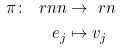Convert formula to latex. <formula><loc_0><loc_0><loc_500><loc_500>\pi \colon \ r n n & \to \ r n \\ e _ { j } & \mapsto v _ { j }</formula> 